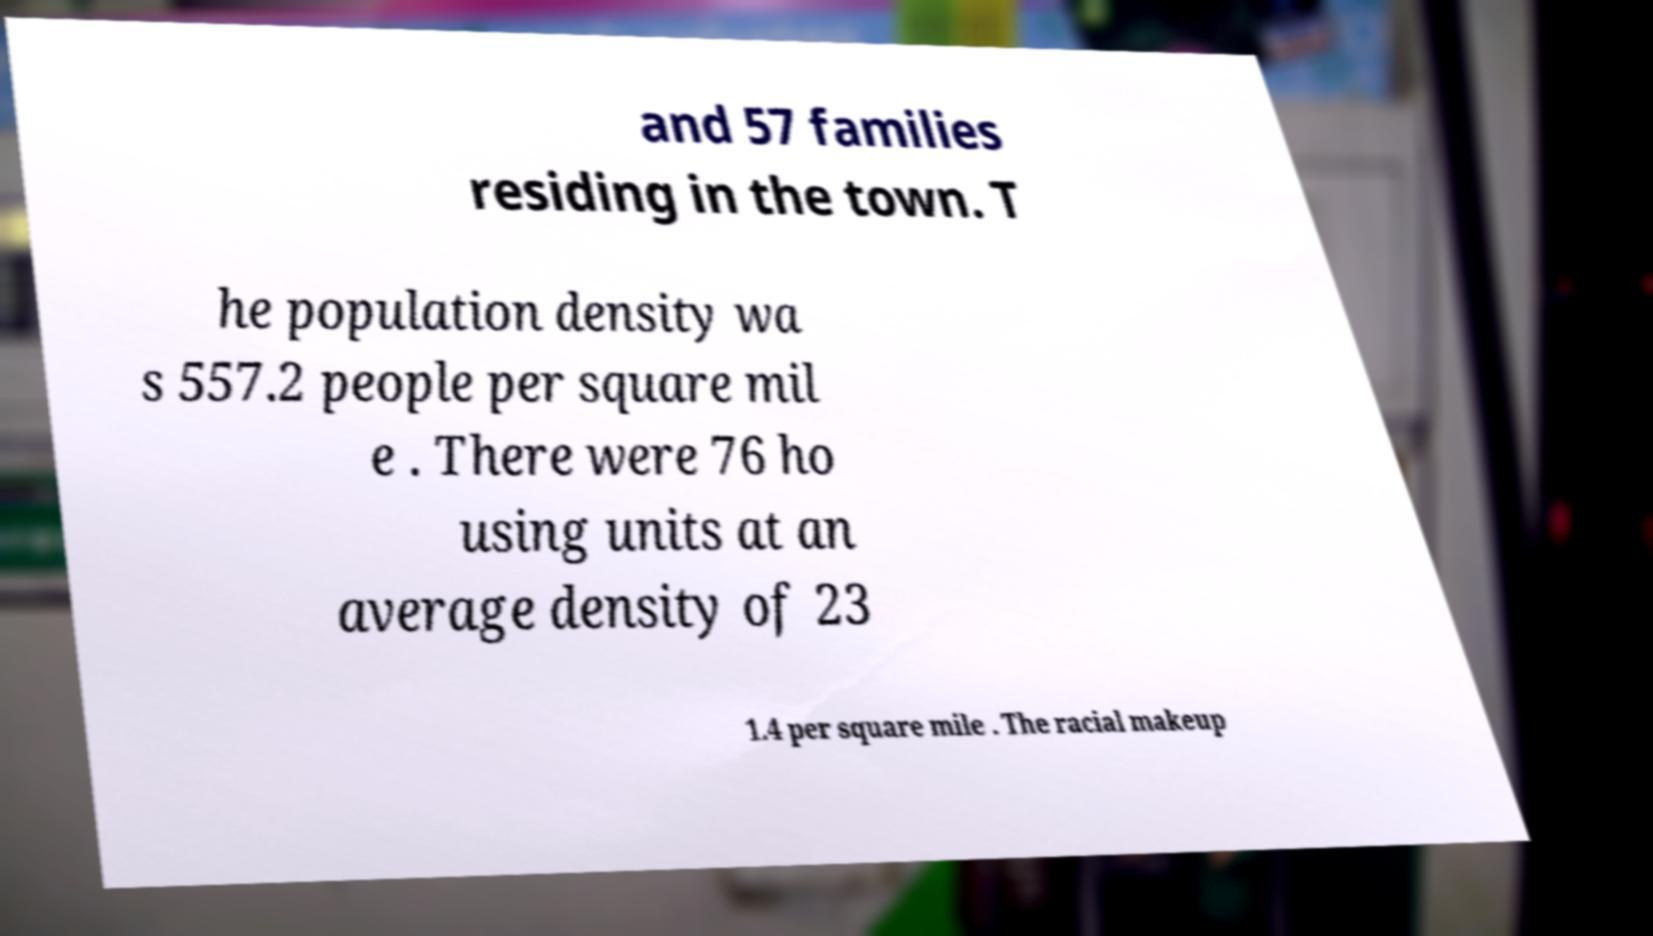Could you extract and type out the text from this image? and 57 families residing in the town. T he population density wa s 557.2 people per square mil e . There were 76 ho using units at an average density of 23 1.4 per square mile . The racial makeup 